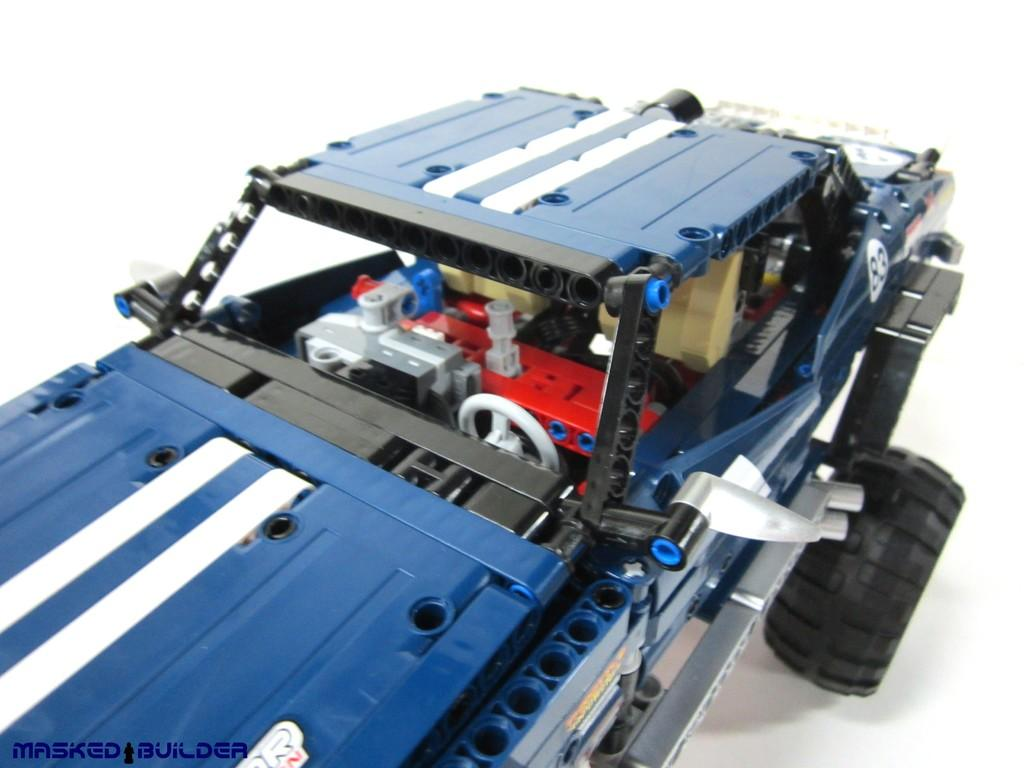What is the main object in the image? There is a toy car in the image. What color is the toy car? The toy car is blue in color. Can you see a flock of birds flying over the toy car in the image? There is no mention of birds or a flock in the image, so we cannot say if they are present or not. 